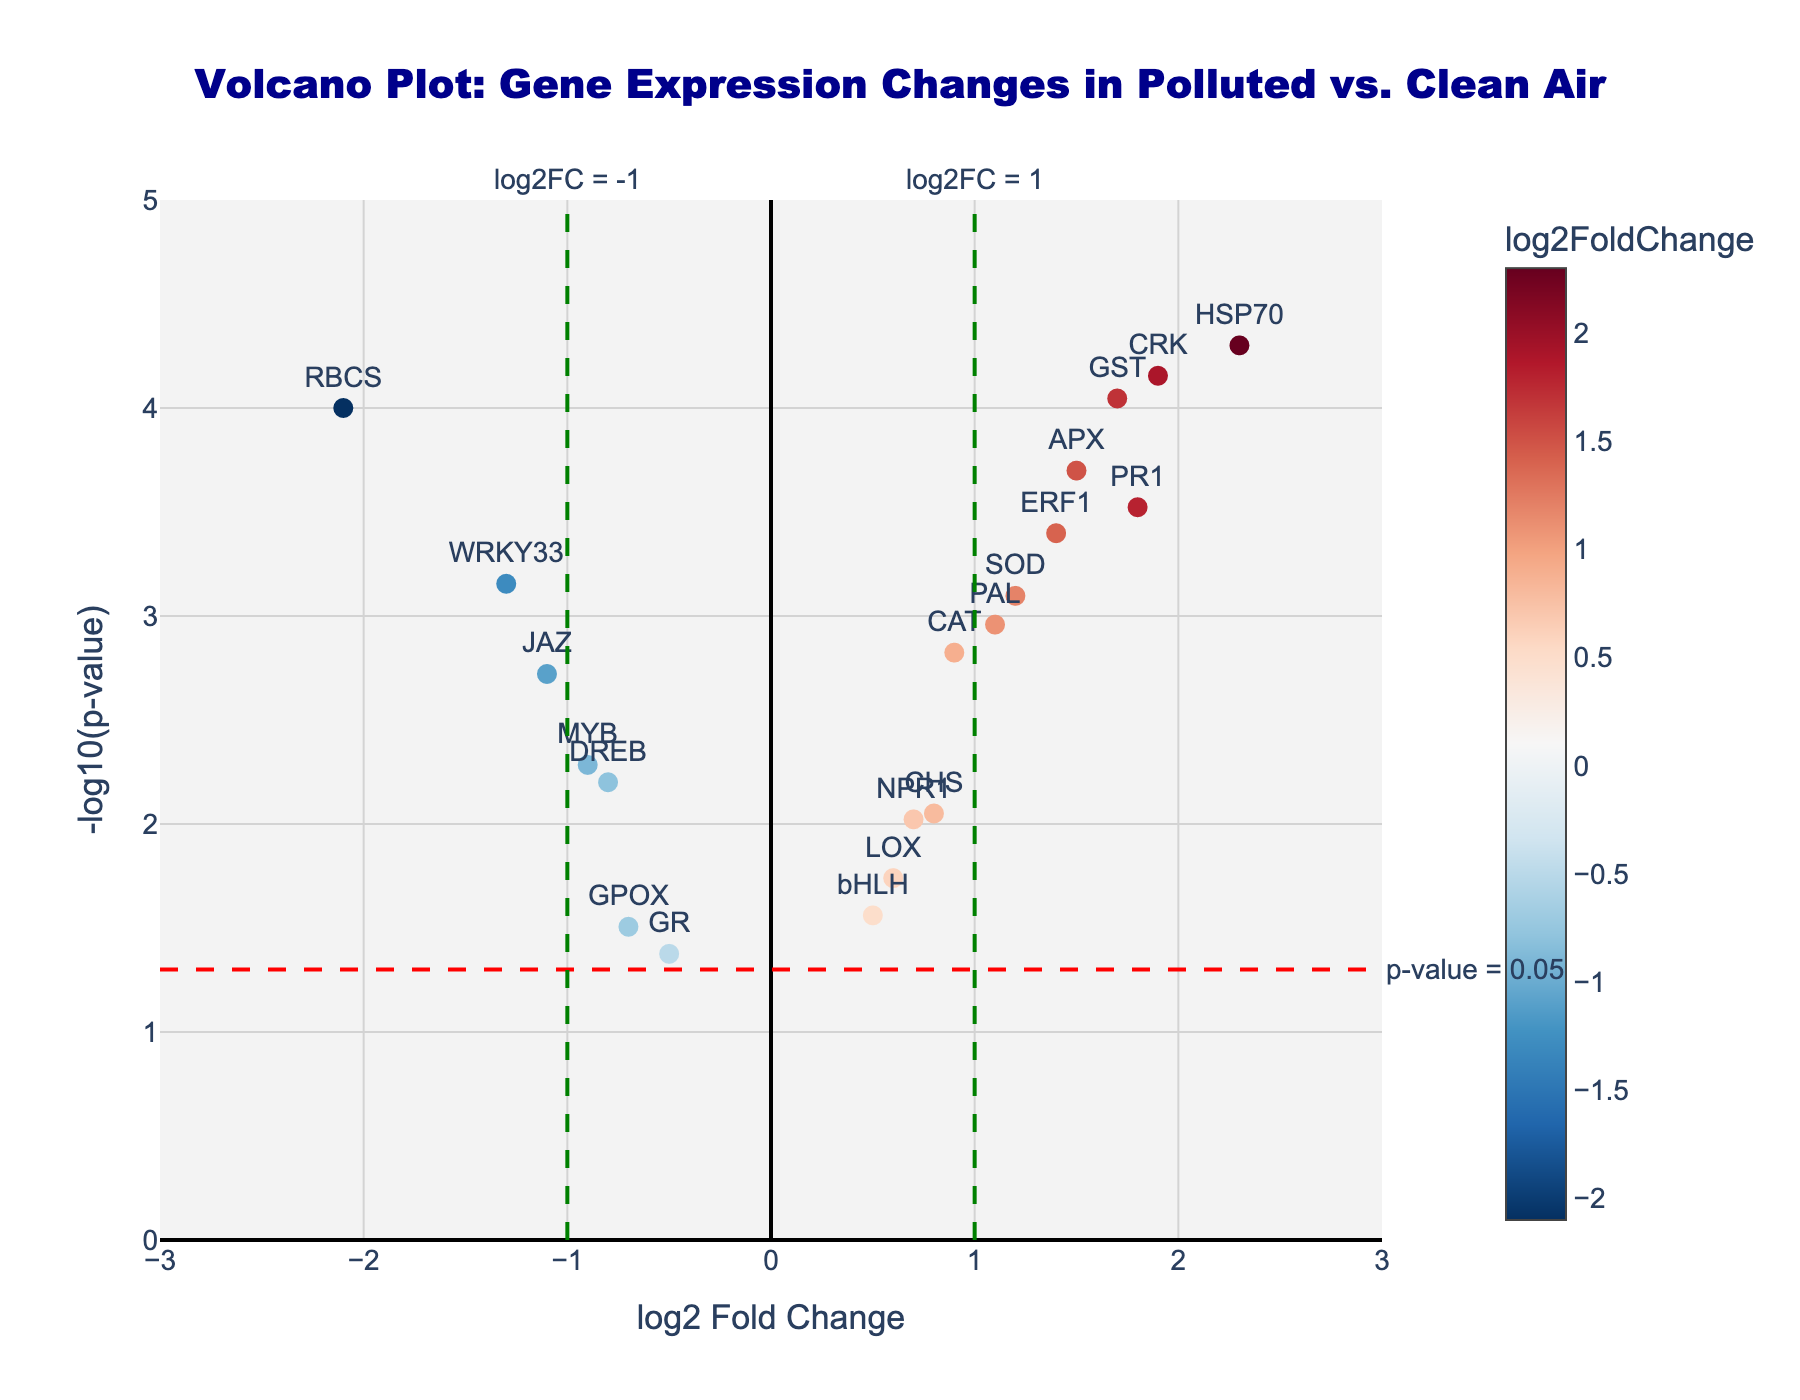What does the title of the figure indicate? The title of the figure reads, "Volcano Plot: Gene Expression Changes in Polluted vs. Clean Air". This indicates that the plot visualizes changes in gene expression in plant leaves when exposed to polluted air compared to clean air. The x-axis likely represents the fold change in gene expression, and the y-axis represents the significance of those changes.
Answer: The plot shows gene expression changes in plant leaves between polluted and clean air environments What is the x-axis representing? The x-axis is labeled "log2 Fold Change", which represents the logarithm (base 2) of the fold change in gene expression between polluted and clean air. Positive values indicate upregulation, while negative values suggest downregulation of genes.
Answer: log2 Fold Change in gene expression What is the y-axis representing? The y-axis is labeled "-log10(p-value)", which represents the negative logarithm (base 10) of the p-value for each gene. Higher values indicate more statistically significant changes in gene expression.
Answer: -log10(p-value) How many genes are shown to be significantly upregulated (log2FC > 1 and p-value < 0.05)? To determine the number of significantly upregulated genes, we look for data points above the red dashed line (labeled p-value = 0.05) and to the right of the green dashed line (labeled log2FC = 1). By examining these criteria, there are three data points meeting these requirements: PR1, APX, and CRK.
Answer: 3 genes Which genes have the most significant changes in expression? The significance of changes in gene expression is indicated by the y-axis values (-log10(p-value)). Higher y-axis values represent more significant changes. The genes HSP70 and CRK have the highest y-axis values, indicating they have the most significant changes in expression.
Answer: HSP70 and CRK Which gene has the largest downregulation, and how significant is this downregulation? The largest downregulation is represented by the most negative log2FC value and a high -log10(p-value). WRKY33 shows the largest downregulation log2FC of -1.3, with a significant y-axis value indicating its downregulation.
Answer: WRKY33 with a log2FC of -1.3 What gene has the highest log2 Fold Change and how statistically significant is it? To identify the gene with the highest log2 Fold Change, check the rightmost point on the x-axis (log2FC). HSP70 has the highest log2FC of 2.3. The y-axis value is also quite high, which indicates a high statistical significance.
Answer: HSP70, highly significant How many genes fall within the non-significant area (p-value > 0.05)? Non-significant genes will be below the horizontal red dashed line indicating p-value = 0.05. By counting the data points below this line and inside the range of log2FC values, there are 3 genes: GPOX, GR, bHLH.
Answer: 3 genes What can be inferred by the color gradient of the data points? The color gradient of the data points corresponds to the log2 Fold Change values, with red indicating lower log2FC and blue indicating higher values (positive or negative). It helps to visualize the extent of upregulation or downregulation in gene expression.
Answer: Red indicates low log2FC, blue indicates high log2FC 